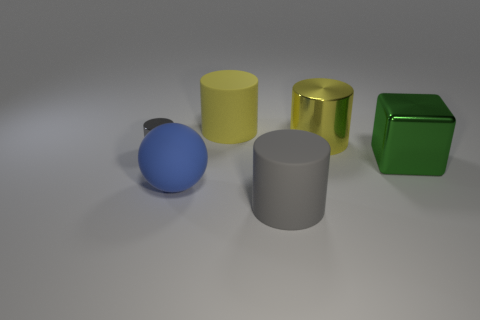Add 2 brown things. How many objects exist? 8 Subtract all cylinders. How many objects are left? 2 Add 1 blue balls. How many blue balls exist? 2 Subtract 0 yellow cubes. How many objects are left? 6 Subtract all tiny brown metallic balls. Subtract all large spheres. How many objects are left? 5 Add 5 balls. How many balls are left? 6 